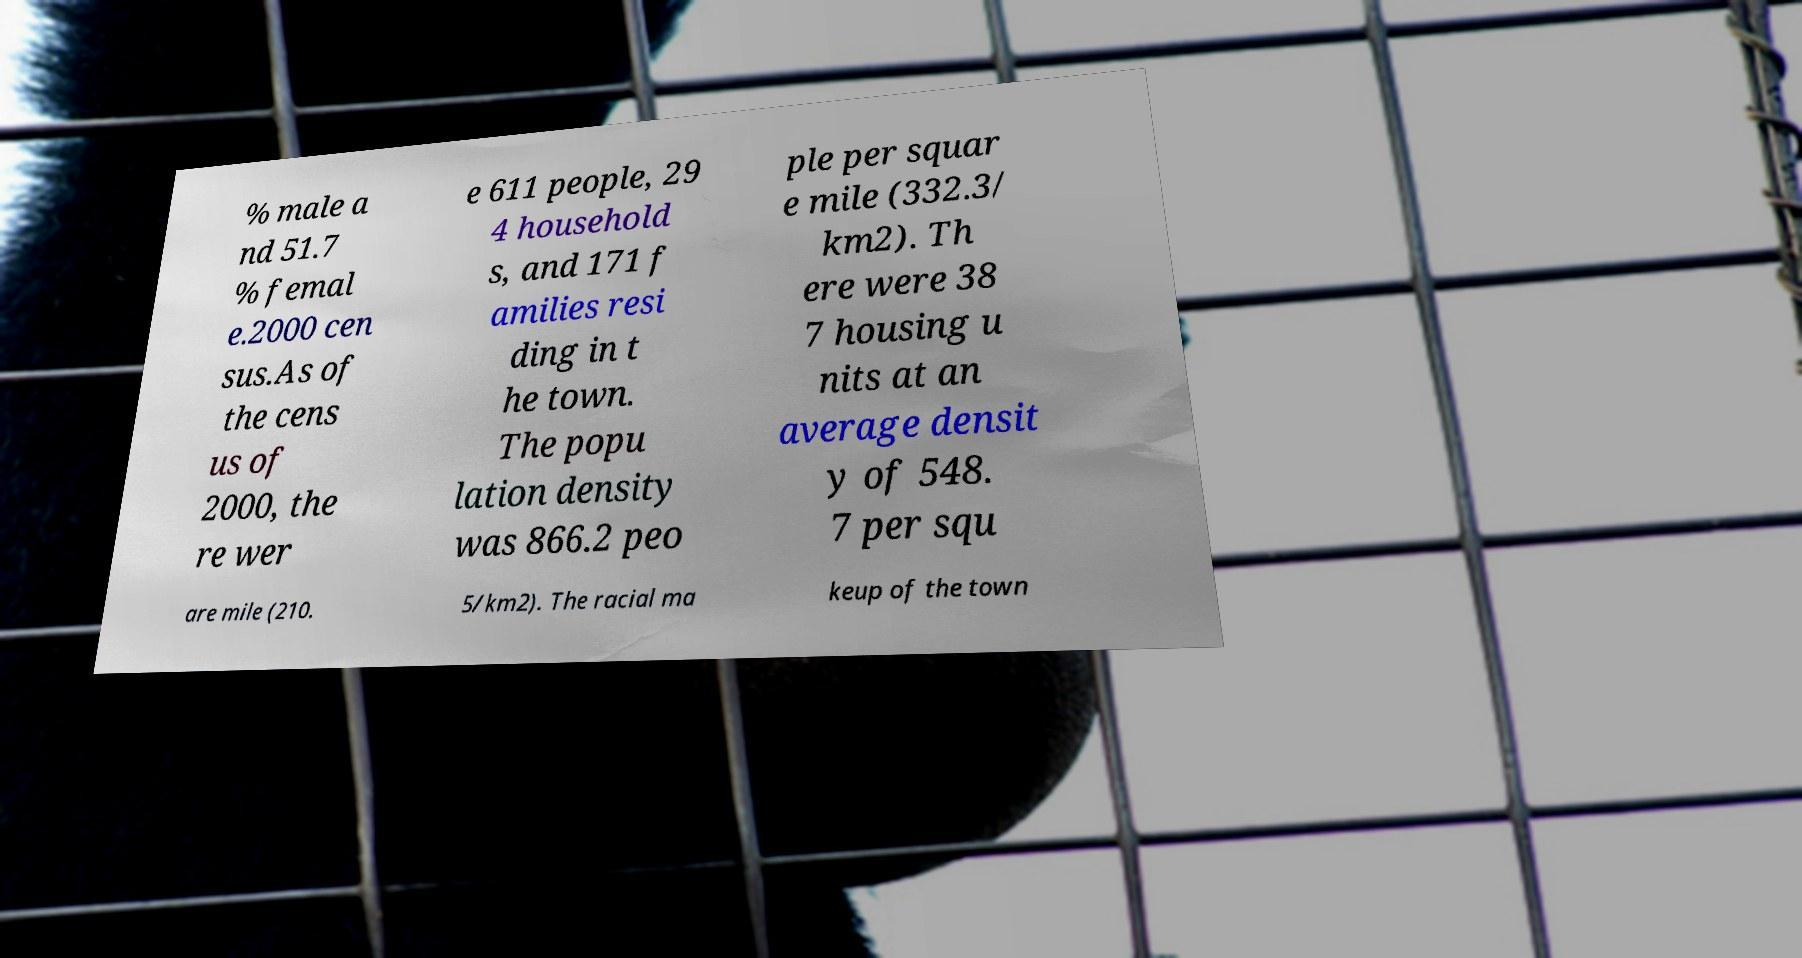Can you read and provide the text displayed in the image?This photo seems to have some interesting text. Can you extract and type it out for me? % male a nd 51.7 % femal e.2000 cen sus.As of the cens us of 2000, the re wer e 611 people, 29 4 household s, and 171 f amilies resi ding in t he town. The popu lation density was 866.2 peo ple per squar e mile (332.3/ km2). Th ere were 38 7 housing u nits at an average densit y of 548. 7 per squ are mile (210. 5/km2). The racial ma keup of the town 